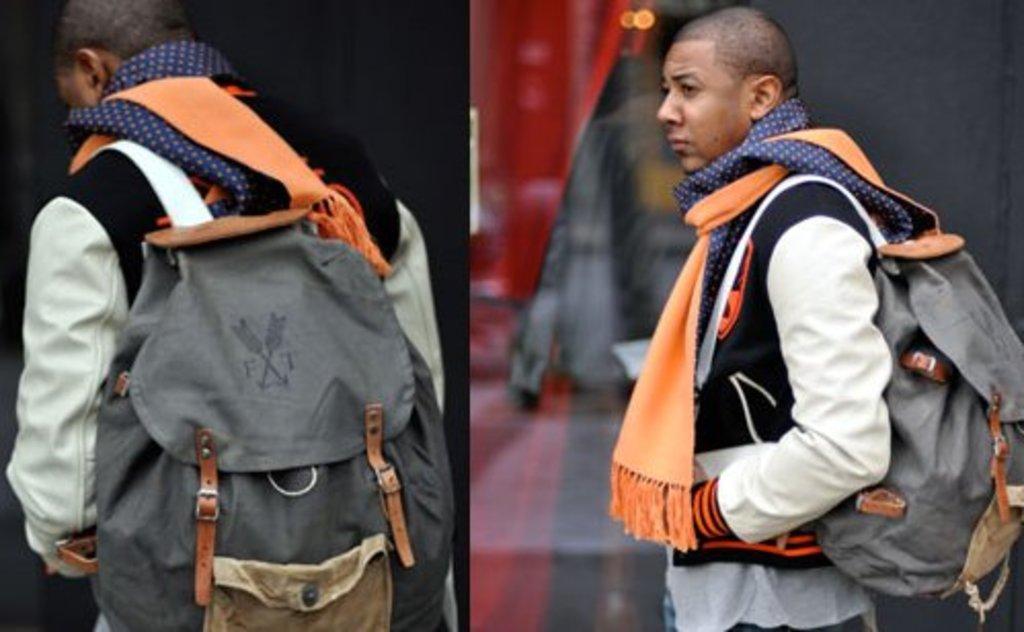Describe the logo on the pack?
Provide a short and direct response. Ft. 